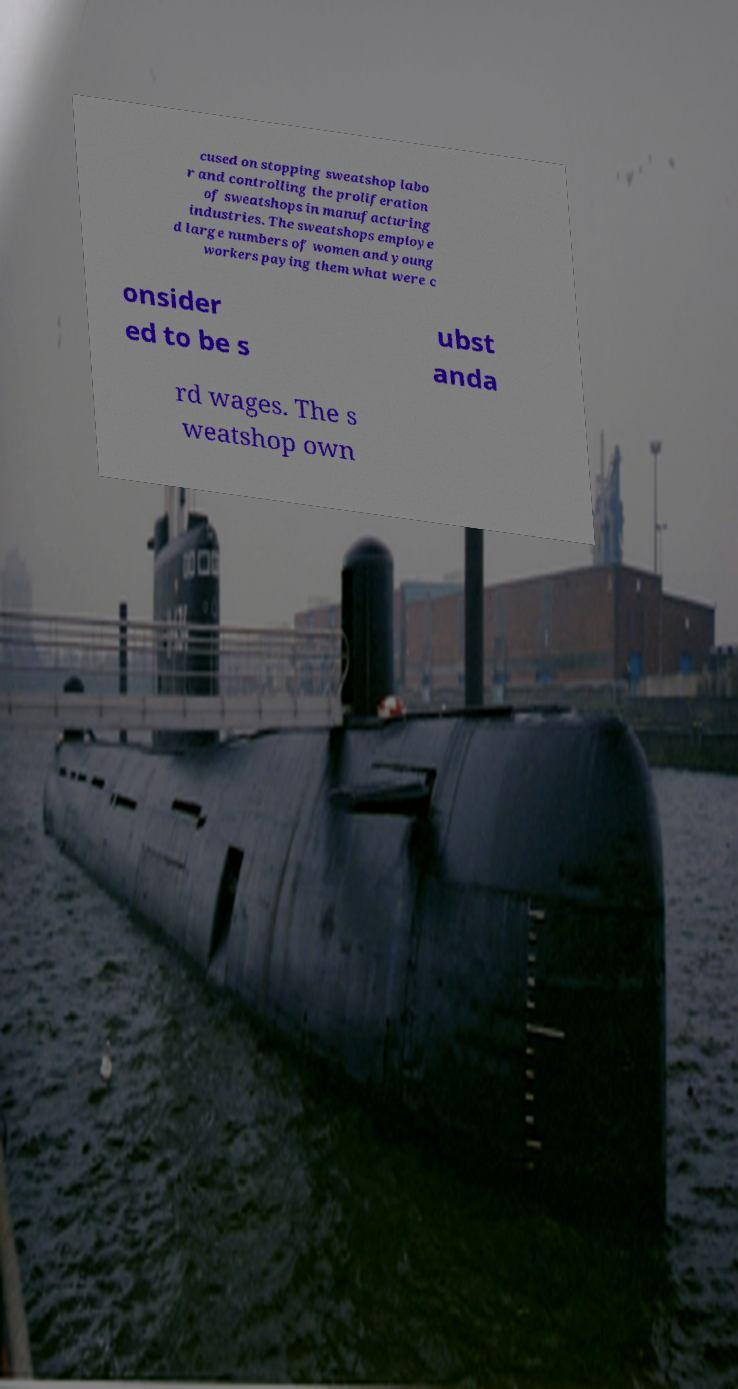What messages or text are displayed in this image? I need them in a readable, typed format. cused on stopping sweatshop labo r and controlling the proliferation of sweatshops in manufacturing industries. The sweatshops employe d large numbers of women and young workers paying them what were c onsider ed to be s ubst anda rd wages. The s weatshop own 